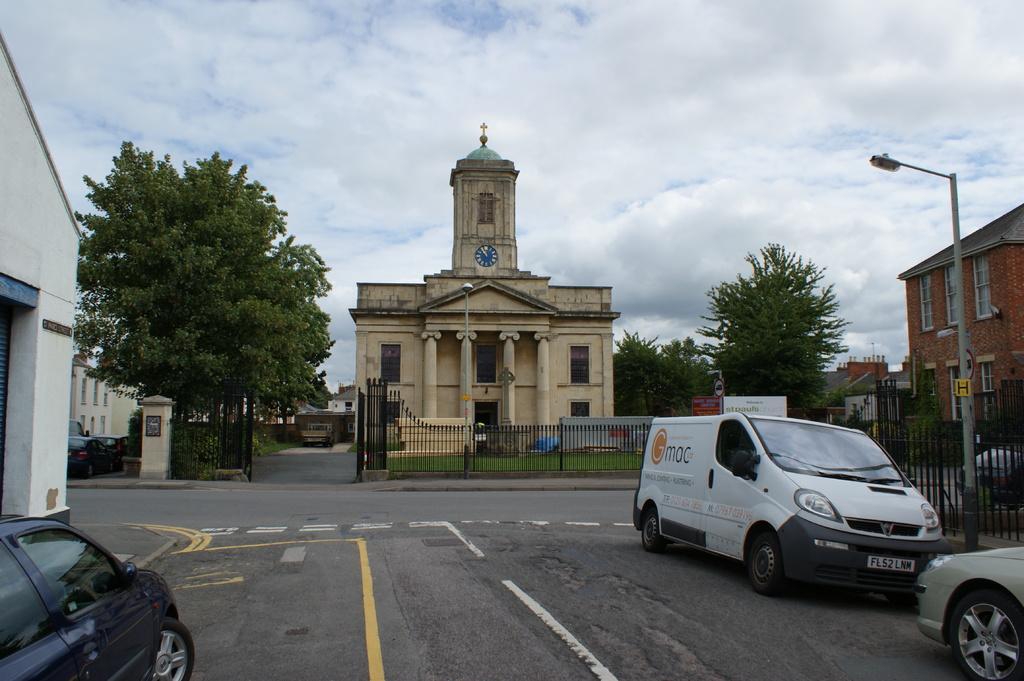Describe this image in one or two sentences. In this picture I can see vehicles and white lines on the road. In the background I can see trees, fence, a gate and buildings. On the right side I can see a street light and the sky in the background. 